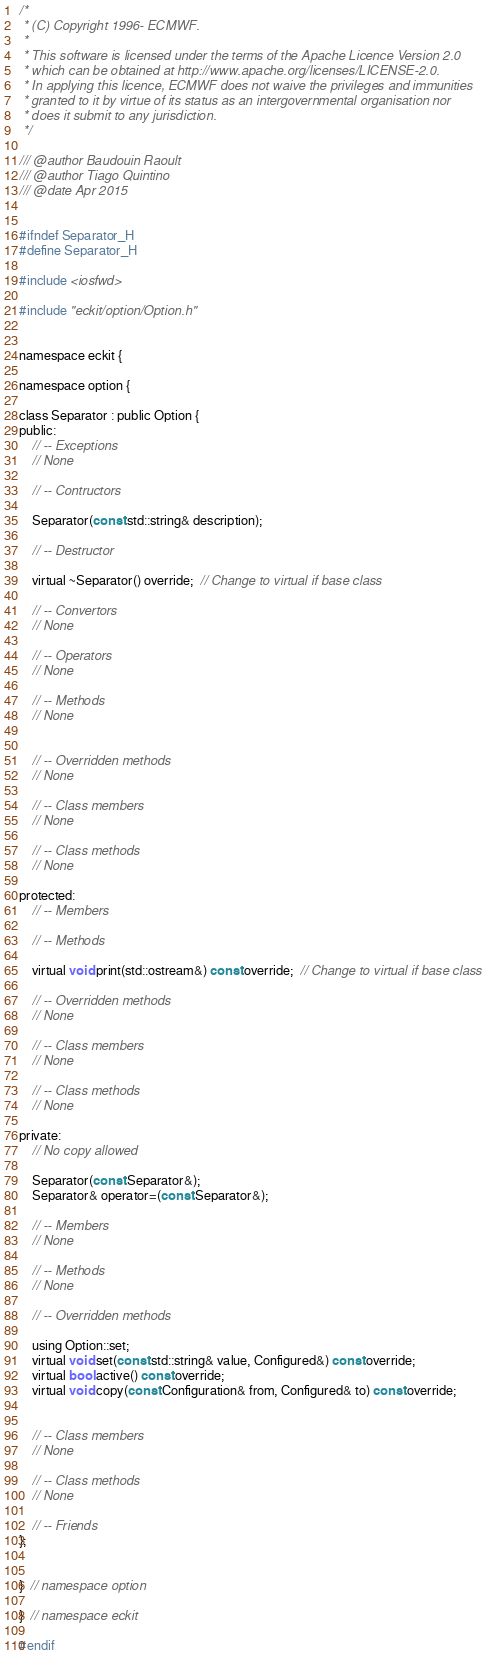<code> <loc_0><loc_0><loc_500><loc_500><_C_>/*
 * (C) Copyright 1996- ECMWF.
 *
 * This software is licensed under the terms of the Apache Licence Version 2.0
 * which can be obtained at http://www.apache.org/licenses/LICENSE-2.0.
 * In applying this licence, ECMWF does not waive the privileges and immunities
 * granted to it by virtue of its status as an intergovernmental organisation nor
 * does it submit to any jurisdiction.
 */

/// @author Baudouin Raoult
/// @author Tiago Quintino
/// @date Apr 2015


#ifndef Separator_H
#define Separator_H

#include <iosfwd>

#include "eckit/option/Option.h"


namespace eckit {

namespace option {

class Separator : public Option {
public:
    // -- Exceptions
    // None

    // -- Contructors

    Separator(const std::string& description);

    // -- Destructor

    virtual ~Separator() override;  // Change to virtual if base class

    // -- Convertors
    // None

    // -- Operators
    // None

    // -- Methods
    // None


    // -- Overridden methods
    // None

    // -- Class members
    // None

    // -- Class methods
    // None

protected:
    // -- Members

    // -- Methods

    virtual void print(std::ostream&) const override;  // Change to virtual if base class

    // -- Overridden methods
    // None

    // -- Class members
    // None

    // -- Class methods
    // None

private:
    // No copy allowed

    Separator(const Separator&);
    Separator& operator=(const Separator&);

    // -- Members
    // None

    // -- Methods
    // None

    // -- Overridden methods

    using Option::set;
    virtual void set(const std::string& value, Configured&) const override;
    virtual bool active() const override;
    virtual void copy(const Configuration& from, Configured& to) const override;


    // -- Class members
    // None

    // -- Class methods
    // None

    // -- Friends
};


}  // namespace option

}  // namespace eckit

#endif
</code> 